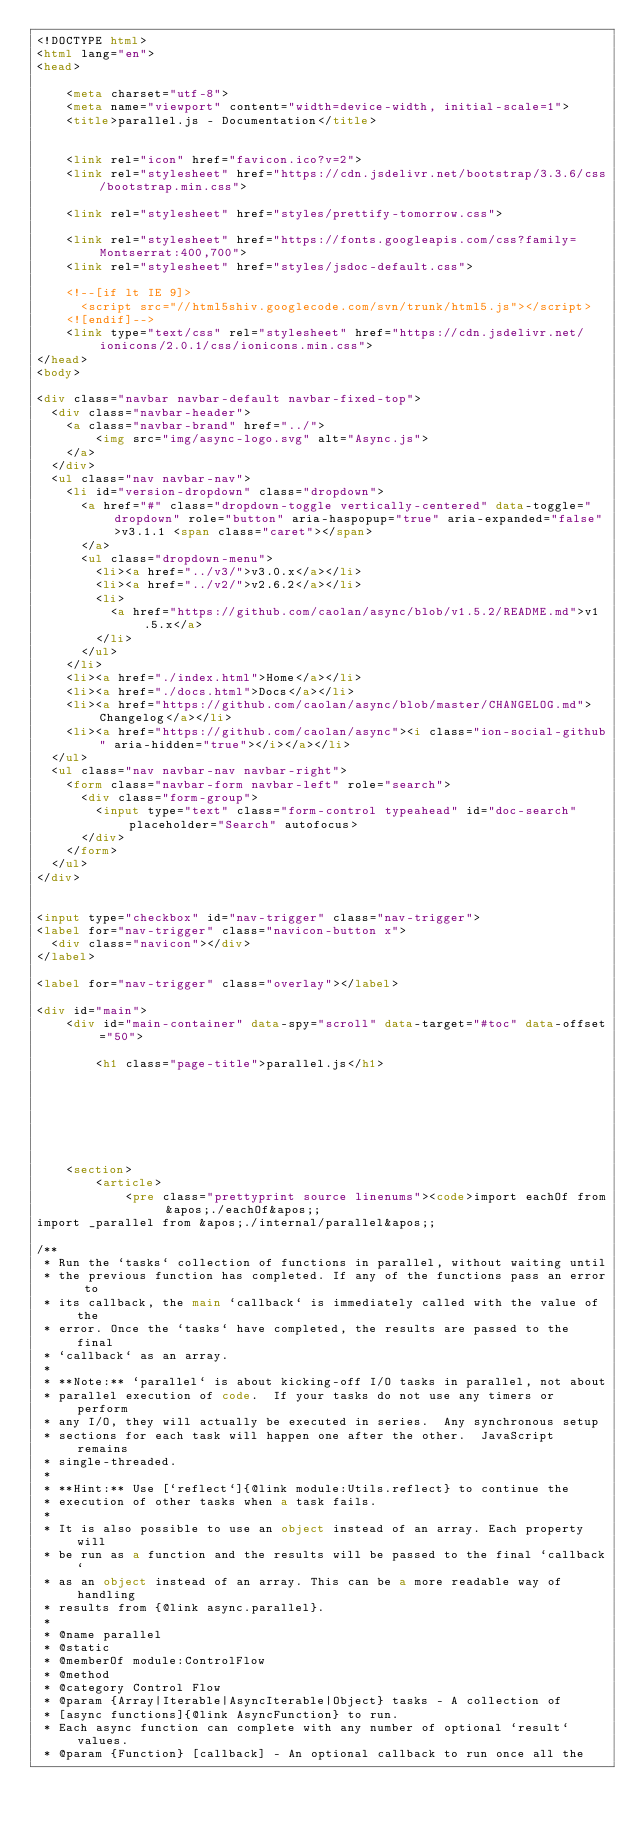Convert code to text. <code><loc_0><loc_0><loc_500><loc_500><_HTML_><!DOCTYPE html>
<html lang="en">
<head>

    <meta charset="utf-8">
    <meta name="viewport" content="width=device-width, initial-scale=1">
    <title>parallel.js - Documentation</title>


    <link rel="icon" href="favicon.ico?v=2">
    <link rel="stylesheet" href="https://cdn.jsdelivr.net/bootstrap/3.3.6/css/bootstrap.min.css">

    <link rel="stylesheet" href="styles/prettify-tomorrow.css">

    <link rel="stylesheet" href="https://fonts.googleapis.com/css?family=Montserrat:400,700">
    <link rel="stylesheet" href="styles/jsdoc-default.css">

    <!--[if lt IE 9]>
      <script src="//html5shiv.googlecode.com/svn/trunk/html5.js"></script>
    <![endif]-->
    <link type="text/css" rel="stylesheet" href="https://cdn.jsdelivr.net/ionicons/2.0.1/css/ionicons.min.css">
</head>
<body>

<div class="navbar navbar-default navbar-fixed-top">
  <div class="navbar-header">
    <a class="navbar-brand" href="../">
        <img src="img/async-logo.svg" alt="Async.js">
    </a>
  </div>
  <ul class="nav navbar-nav">
    <li id="version-dropdown" class="dropdown">
      <a href="#" class="dropdown-toggle vertically-centered" data-toggle="dropdown" role="button" aria-haspopup="true" aria-expanded="false">v3.1.1 <span class="caret"></span>
      </a>
      <ul class="dropdown-menu">
        <li><a href="../v3/">v3.0.x</a></li>
        <li><a href="../v2/">v2.6.2</a></li>
        <li>
          <a href="https://github.com/caolan/async/blob/v1.5.2/README.md">v1.5.x</a>
        </li>
      </ul>
    </li>
    <li><a href="./index.html">Home</a></li>
    <li><a href="./docs.html">Docs</a></li>
    <li><a href="https://github.com/caolan/async/blob/master/CHANGELOG.md">Changelog</a></li>
    <li><a href="https://github.com/caolan/async"><i class="ion-social-github" aria-hidden="true"></i></a></li>
  </ul>
  <ul class="nav navbar-nav navbar-right">
    <form class="navbar-form navbar-left" role="search">
      <div class="form-group">
        <input type="text" class="form-control typeahead" id="doc-search" placeholder="Search" autofocus>
      </div>
    </form>
  </ul>
</div>


<input type="checkbox" id="nav-trigger" class="nav-trigger">
<label for="nav-trigger" class="navicon-button x">
  <div class="navicon"></div>
</label>

<label for="nav-trigger" class="overlay"></label>

<div id="main">
    <div id="main-container" data-spy="scroll" data-target="#toc" data-offset="50">
        
        <h1 class="page-title">parallel.js</h1>
        

        



    
    <section>
        <article>
            <pre class="prettyprint source linenums"><code>import eachOf from &apos;./eachOf&apos;;
import _parallel from &apos;./internal/parallel&apos;;

/**
 * Run the `tasks` collection of functions in parallel, without waiting until
 * the previous function has completed. If any of the functions pass an error to
 * its callback, the main `callback` is immediately called with the value of the
 * error. Once the `tasks` have completed, the results are passed to the final
 * `callback` as an array.
 *
 * **Note:** `parallel` is about kicking-off I/O tasks in parallel, not about
 * parallel execution of code.  If your tasks do not use any timers or perform
 * any I/O, they will actually be executed in series.  Any synchronous setup
 * sections for each task will happen one after the other.  JavaScript remains
 * single-threaded.
 *
 * **Hint:** Use [`reflect`]{@link module:Utils.reflect} to continue the
 * execution of other tasks when a task fails.
 *
 * It is also possible to use an object instead of an array. Each property will
 * be run as a function and the results will be passed to the final `callback`
 * as an object instead of an array. This can be a more readable way of handling
 * results from {@link async.parallel}.
 *
 * @name parallel
 * @static
 * @memberOf module:ControlFlow
 * @method
 * @category Control Flow
 * @param {Array|Iterable|AsyncIterable|Object} tasks - A collection of
 * [async functions]{@link AsyncFunction} to run.
 * Each async function can complete with any number of optional `result` values.
 * @param {Function} [callback] - An optional callback to run once all the</code> 